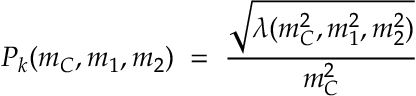<formula> <loc_0><loc_0><loc_500><loc_500>P _ { k } ( m _ { C } , m _ { 1 } , m _ { 2 } ) \, = \, \frac { \sqrt { \lambda ( m _ { C } ^ { 2 } , m _ { 1 } ^ { 2 } , m _ { 2 } ^ { 2 } ) } } { m _ { C } ^ { 2 } }</formula> 